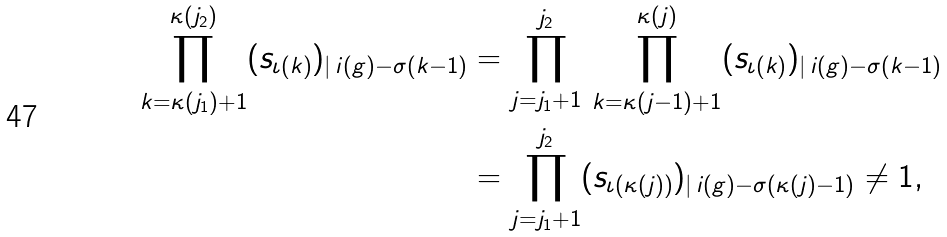<formula> <loc_0><loc_0><loc_500><loc_500>\prod _ { k = \kappa ( j _ { 1 } ) + 1 } ^ { \kappa ( j _ { 2 } ) } ( s _ { \iota ( k ) } ) _ { | \, i ( g ) - \sigma ( k - 1 ) } & = \prod _ { j = j _ { 1 } + 1 } ^ { j _ { 2 } } \, \prod _ { k = \kappa ( j - 1 ) + 1 } ^ { \kappa ( j ) } ( s _ { \iota ( k ) } ) _ { | \, i ( g ) - \sigma ( k - 1 ) } \\ & = \prod _ { j = j _ { 1 } + 1 } ^ { j _ { 2 } } ( s _ { \iota ( \kappa ( j ) ) } ) _ { | \, i ( g ) - \sigma ( \kappa ( j ) - 1 ) } \ne 1 ,</formula> 